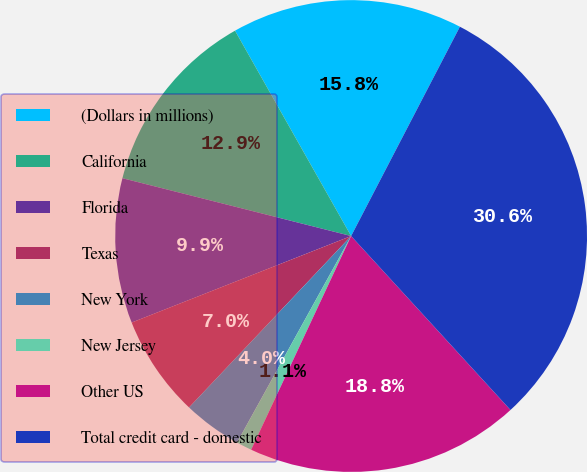Convert chart. <chart><loc_0><loc_0><loc_500><loc_500><pie_chart><fcel>(Dollars in millions)<fcel>California<fcel>Florida<fcel>Texas<fcel>New York<fcel>New Jersey<fcel>Other US<fcel>Total credit card - domestic<nl><fcel>15.82%<fcel>12.87%<fcel>9.92%<fcel>6.97%<fcel>4.02%<fcel>1.07%<fcel>18.77%<fcel>30.57%<nl></chart> 